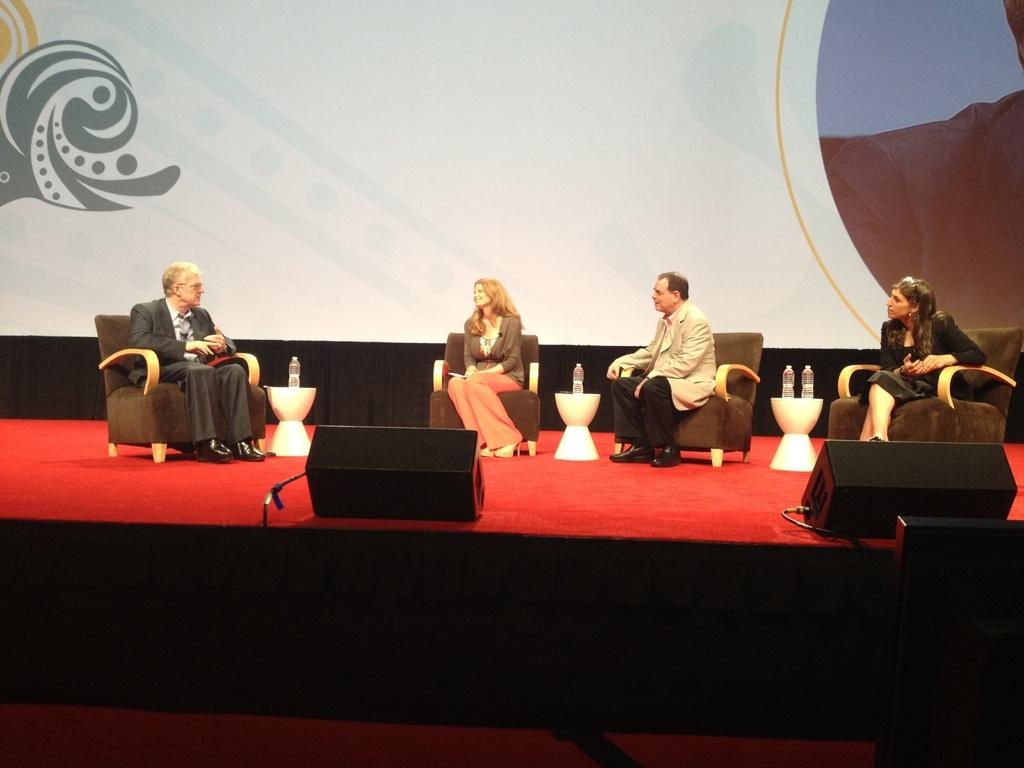What are the people on the stage doing? The people on the stage are sitting on chairs. What can be seen on the table between the chairs? There are water bottles on the table between the chairs. What is on the floor in front of the stage? There is a red carpet on the floor. What is the background of the stage decorated with? There is wallpaper in the background. What type of government is being discussed on the stage? There is no indication in the image that a discussion about government is taking place. 